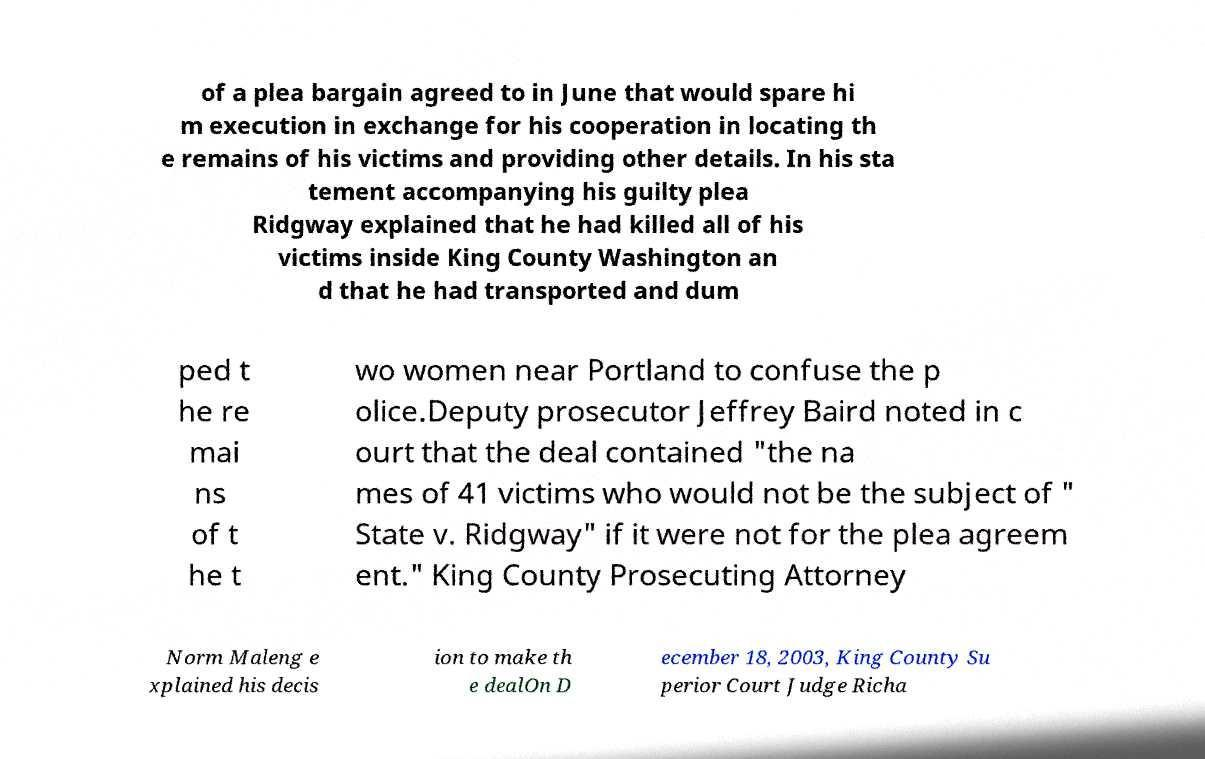Please identify and transcribe the text found in this image. of a plea bargain agreed to in June that would spare hi m execution in exchange for his cooperation in locating th e remains of his victims and providing other details. In his sta tement accompanying his guilty plea Ridgway explained that he had killed all of his victims inside King County Washington an d that he had transported and dum ped t he re mai ns of t he t wo women near Portland to confuse the p olice.Deputy prosecutor Jeffrey Baird noted in c ourt that the deal contained "the na mes of 41 victims who would not be the subject of " State v. Ridgway" if it were not for the plea agreem ent." King County Prosecuting Attorney Norm Maleng e xplained his decis ion to make th e dealOn D ecember 18, 2003, King County Su perior Court Judge Richa 